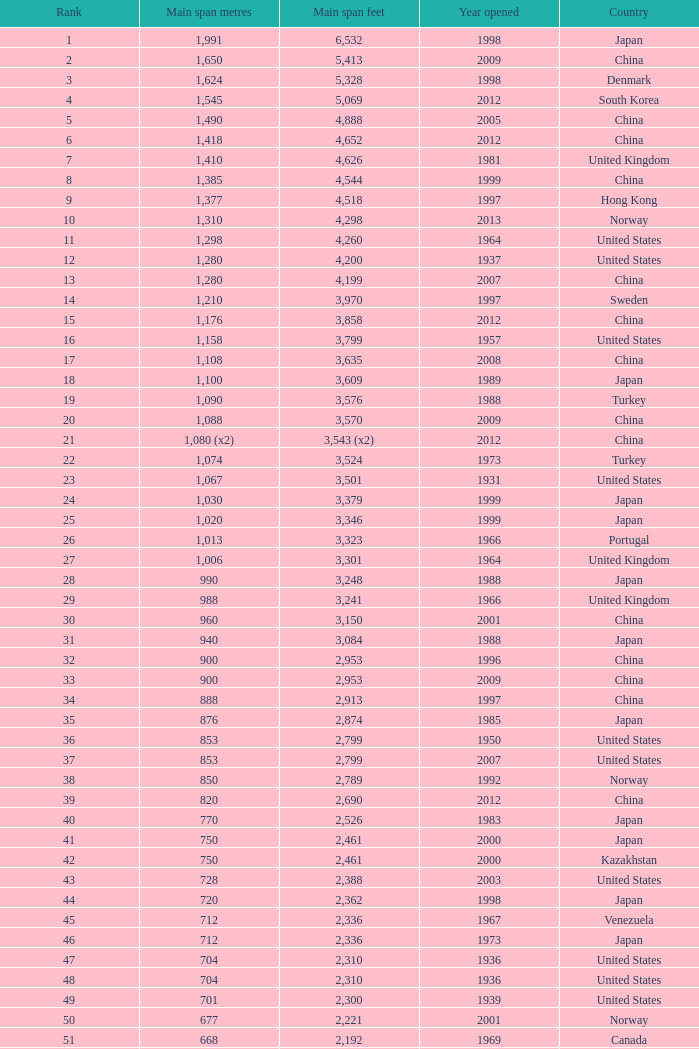What is the top position from the year exceeding 2010 with 430 primary span metres? 94.0. 